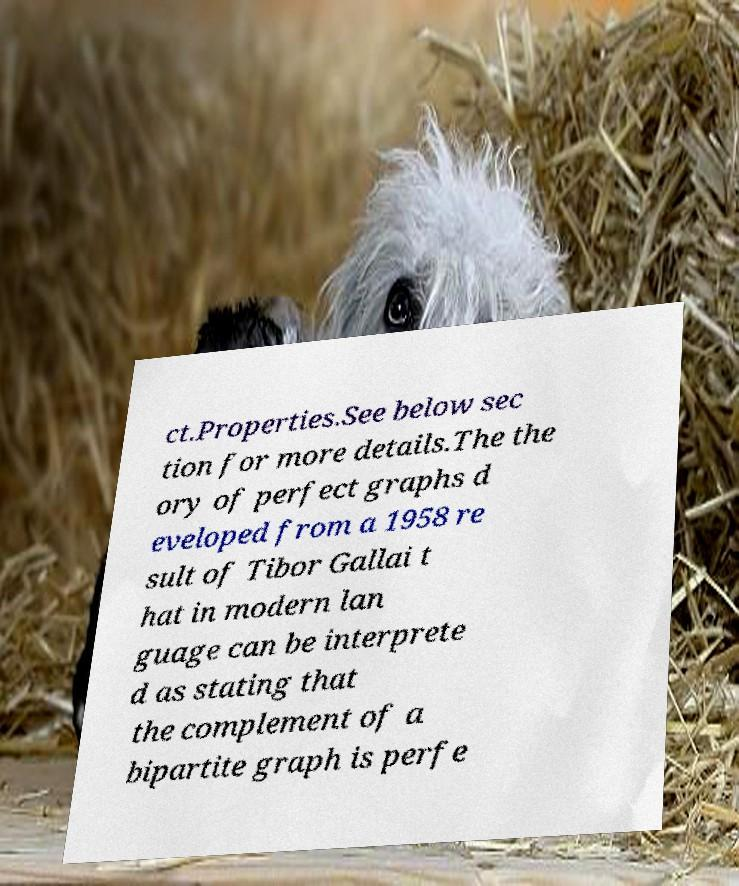Can you read and provide the text displayed in the image?This photo seems to have some interesting text. Can you extract and type it out for me? ct.Properties.See below sec tion for more details.The the ory of perfect graphs d eveloped from a 1958 re sult of Tibor Gallai t hat in modern lan guage can be interprete d as stating that the complement of a bipartite graph is perfe 